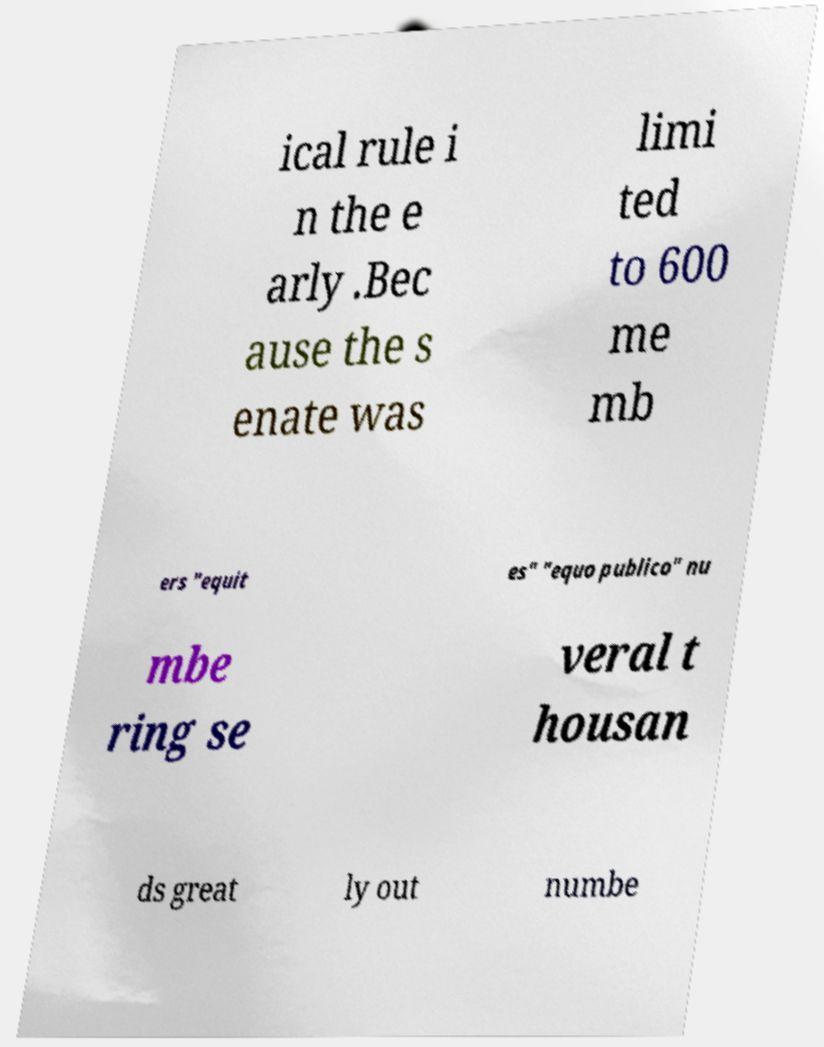I need the written content from this picture converted into text. Can you do that? ical rule i n the e arly .Bec ause the s enate was limi ted to 600 me mb ers "equit es" "equo publico" nu mbe ring se veral t housan ds great ly out numbe 